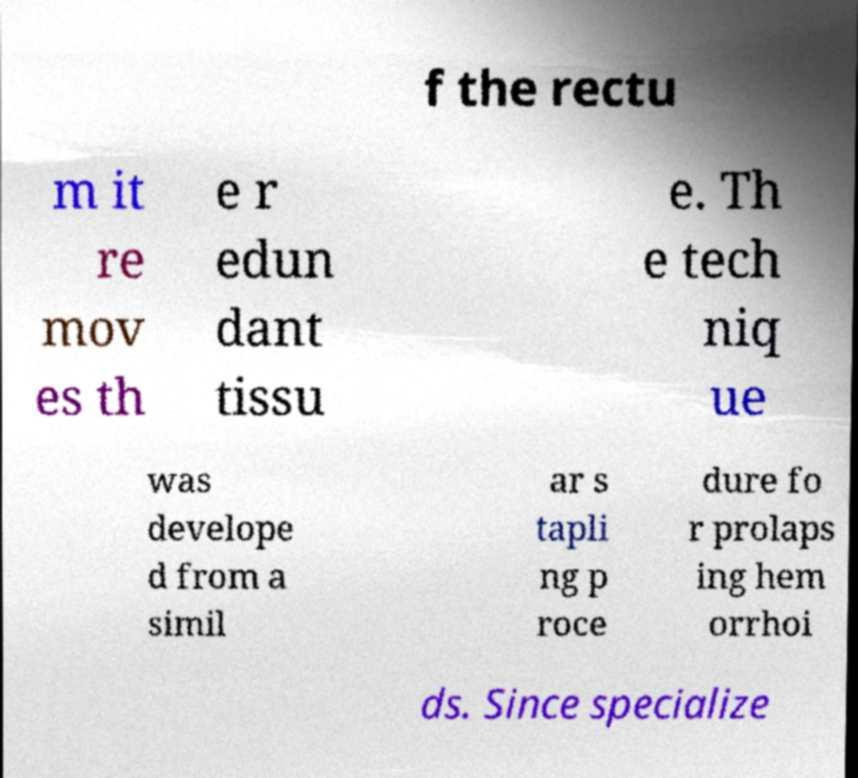Can you accurately transcribe the text from the provided image for me? f the rectu m it re mov es th e r edun dant tissu e. Th e tech niq ue was develope d from a simil ar s tapli ng p roce dure fo r prolaps ing hem orrhoi ds. Since specialize 